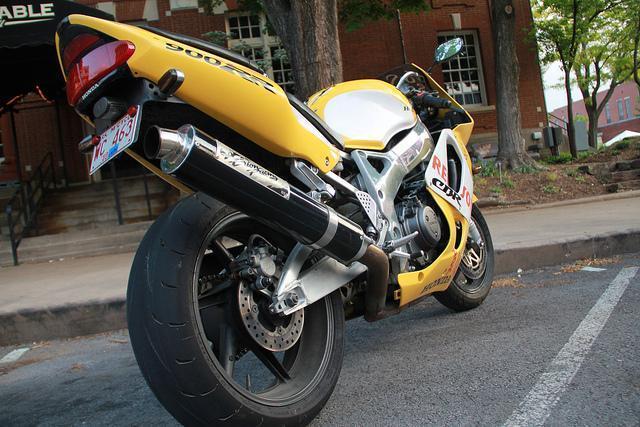How many bottles are on the table?
Give a very brief answer. 0. 